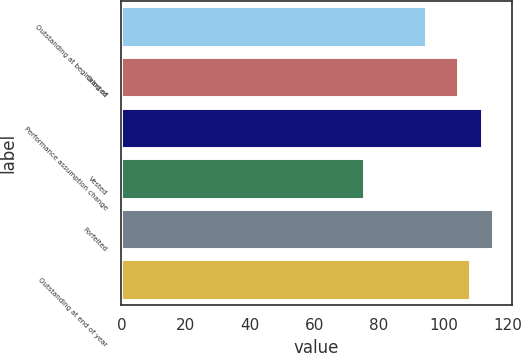Convert chart to OTSL. <chart><loc_0><loc_0><loc_500><loc_500><bar_chart><fcel>Outstanding at beginning of<fcel>Granted<fcel>Performance assumption change<fcel>Vested<fcel>Forfeited<fcel>Outstanding at end of year<nl><fcel>94.48<fcel>104.68<fcel>111.88<fcel>75.4<fcel>115.48<fcel>108.28<nl></chart> 